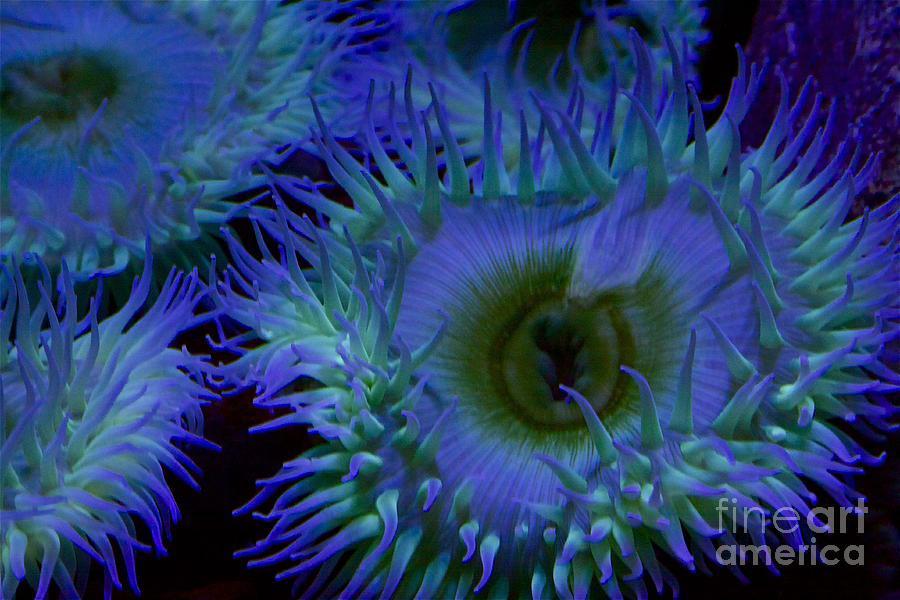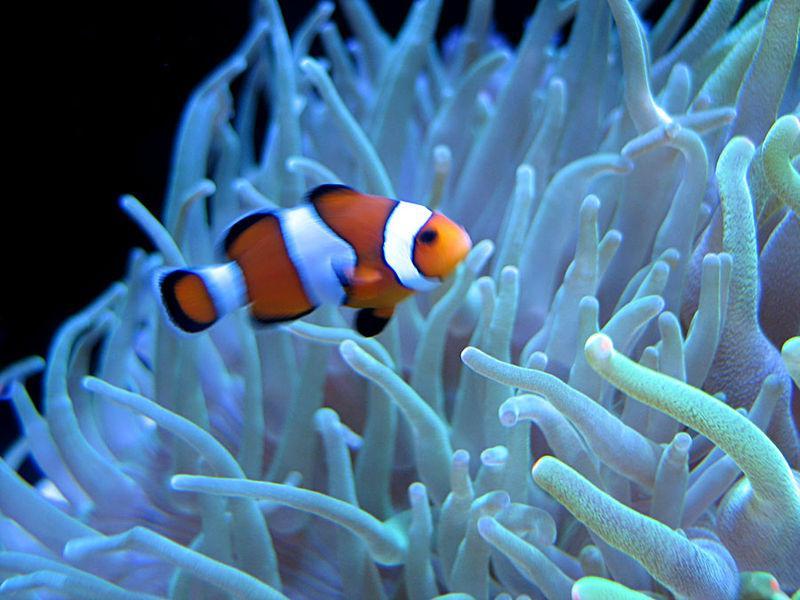The first image is the image on the left, the second image is the image on the right. Given the left and right images, does the statement "In at least one image there is a single orange and white cloud fish swimming above a single coral." hold true? Answer yes or no. Yes. The first image is the image on the left, the second image is the image on the right. Considering the images on both sides, is "One image feature a clown fish next to a sea anemone" valid? Answer yes or no. Yes. 